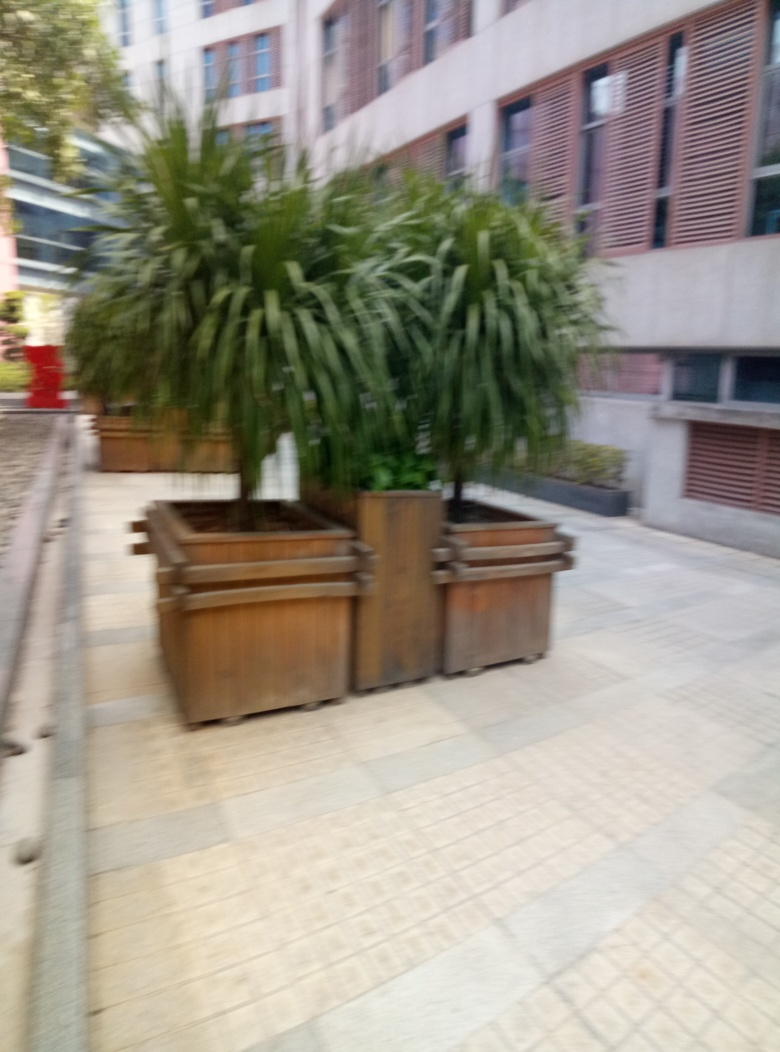How would you describe the clarity of the image?
A. Crystal clear
B. Significantly blurred
C. Slightly blurry
D. Perfectly sharp The image is significantly blurred, perhaps due to camera shake or motion during the capture process. The blurring affects both the foreground, where wooden planters and green plants are out of focus, and the background, which shows an indistinct building facade. The lack of sharpness extends uniformly across the entire frame, indicating that the blurring was not confined to a specific area. 